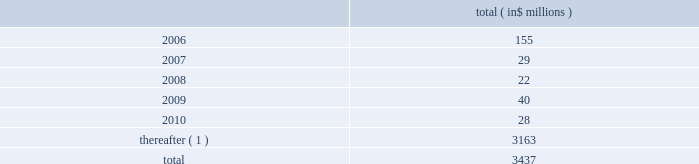Celanese corporation and subsidiaries notes to consolidated financial statements ( continued ) 2022 amend certain material agreements governing bcp crystal 2019s indebtedness ; 2022 change the business conducted by celanese holdings and its subsidiaries ; and 2022 enter into hedging agreements that restrict dividends from subsidiaries .
In addition , the senior credit facilities require bcp crystal to maintain the following financial covenants : a maximum total leverage ratio , a maximum bank debt leverage ratio , a minimum interest coverage ratio and maximum capital expenditures limitation .
The maximum consolidated net bank debt to adjusted ebitda ratio , as defined , previously required under the senior credit facilities , was eliminated when the company amended the facilities in january 2005 .
As of december 31 , 2005 , the company was in compliance with all of the financial covenants related to its debt agreements .
The maturation of the company 2019s debt , including short term borrowings , is as follows : ( in $ millions ) .
( 1 ) includes $ 2 million purchase accounting adjustment to assumed debt .
17 .
Benefit obligations pension obligations .
Pension obligations are established for benefits payable in the form of retirement , disability and surviving dependent pensions .
The benefits offered vary according to the legal , fiscal and economic conditions of each country .
The commitments result from participation in defined contribution and defined benefit plans , primarily in the u.s .
Benefits are dependent on years of service and the employee 2019s compensation .
Supplemental retirement benefits provided to certain employees are non-qualified for u.s .
Tax purposes .
Separate trusts have been established for some non-qualified plans .
Defined benefit pension plans exist at certain locations in north america and europe .
As of december 31 , 2005 , the company 2019s u.s .
Qualified pension plan represented greater than 85% ( 85 % ) and 75% ( 75 % ) of celanese 2019s pension plan assets and liabilities , respectively .
Independent trusts or insurance companies administer the majority of these plans .
Actuarial valuations for these plans are prepared annually .
The company sponsors various defined contribution plans in europe and north america covering certain employees .
Employees may contribute to these plans and the company will match these contributions in varying amounts .
Contributions to the defined contribution plans are based on specified percentages of employee contributions and they aggregated $ 12 million for the year ended decem- ber 31 , 2005 , $ 8 million for the nine months ended december 31 , 2004 , $ 3 million for the three months ended march 31 , 2004 and $ 11 million for the year ended december 31 , 2003 .
In connection with the acquisition of cag , the purchaser agreed to pre-fund $ 463 million of certain pension obligations .
During the nine months ended december 31 , 2004 , $ 409 million was pre-funded to the company 2019s pension plans .
The company contributed an additional $ 54 million to the non-qualified pension plan 2019s rabbi trusts in february 2005 .
In connection with the company 2019s acquisition of vinamul and acetex , the company assumed certain assets and obligations related to the acquired pension plans .
The company recorded liabilities of $ 128 million for these pension plans .
Total pension assets acquired amounted to $ 85 million. .
What is the net liability for pension plan resulting from acquisition of vinamul and acetex? 
Computations: (128 - 85)
Answer: 43.0. 